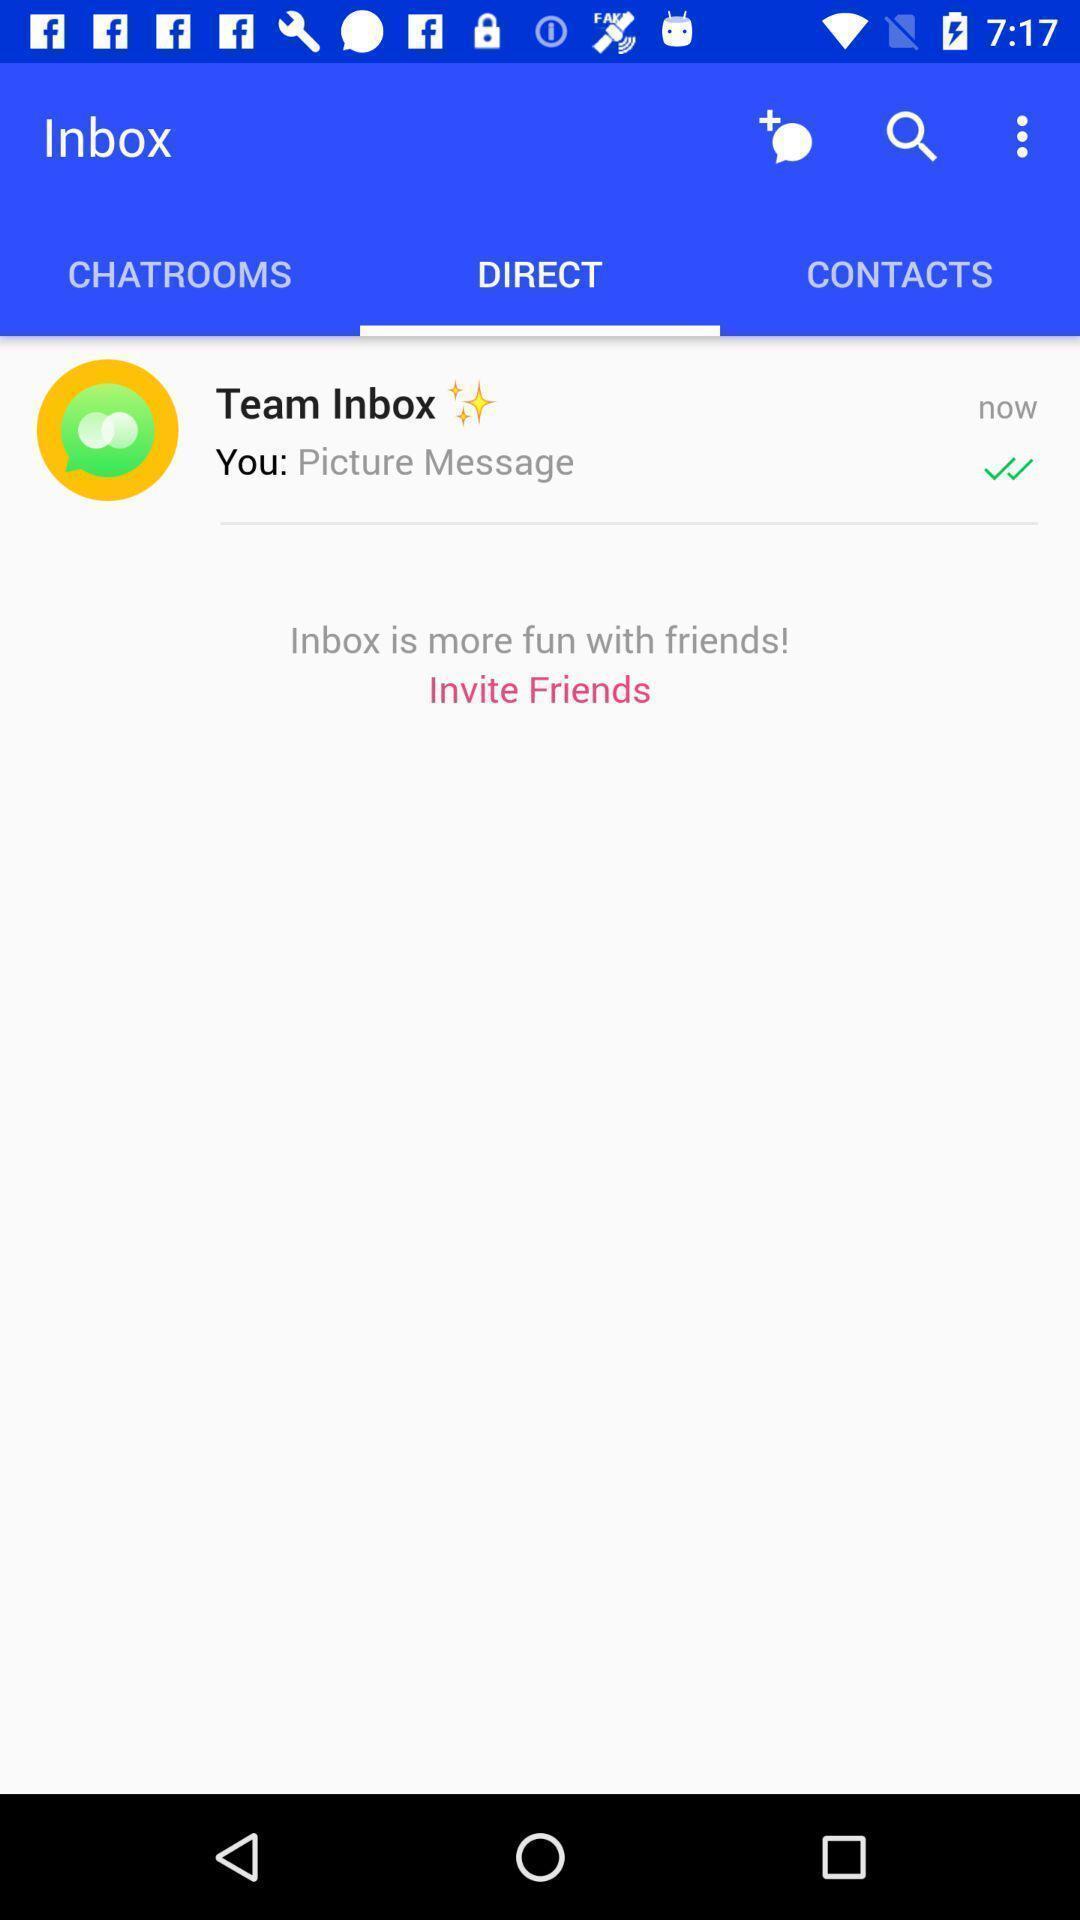Summarize the main components in this picture. Page showing the team inbox in direct column. 